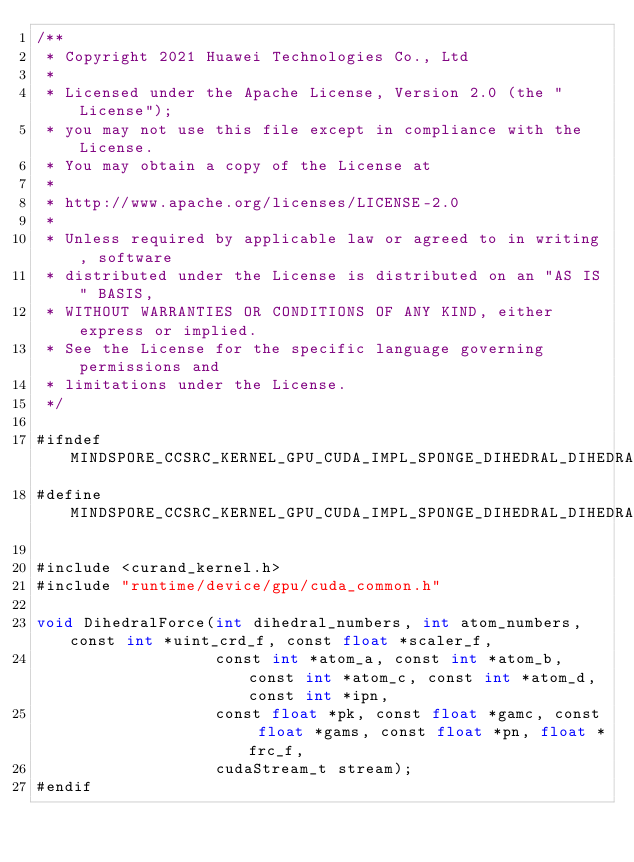<code> <loc_0><loc_0><loc_500><loc_500><_Cuda_>/**
 * Copyright 2021 Huawei Technologies Co., Ltd
 *
 * Licensed under the Apache License, Version 2.0 (the "License");
 * you may not use this file except in compliance with the License.
 * You may obtain a copy of the License at
 *
 * http://www.apache.org/licenses/LICENSE-2.0
 *
 * Unless required by applicable law or agreed to in writing, software
 * distributed under the License is distributed on an "AS IS" BASIS,
 * WITHOUT WARRANTIES OR CONDITIONS OF ANY KIND, either express or implied.
 * See the License for the specific language governing permissions and
 * limitations under the License.
 */

#ifndef MINDSPORE_CCSRC_KERNEL_GPU_CUDA_IMPL_SPONGE_DIHEDRAL_DIHEDRAL_FORCE_IMPL_H_
#define MINDSPORE_CCSRC_KERNEL_GPU_CUDA_IMPL_SPONGE_DIHEDRAL_DIHEDRAL_FORCE_IMPL_H_

#include <curand_kernel.h>
#include "runtime/device/gpu/cuda_common.h"

void DihedralForce(int dihedral_numbers, int atom_numbers, const int *uint_crd_f, const float *scaler_f,
                   const int *atom_a, const int *atom_b, const int *atom_c, const int *atom_d, const int *ipn,
                   const float *pk, const float *gamc, const float *gams, const float *pn, float *frc_f,
                   cudaStream_t stream);
#endif
</code> 